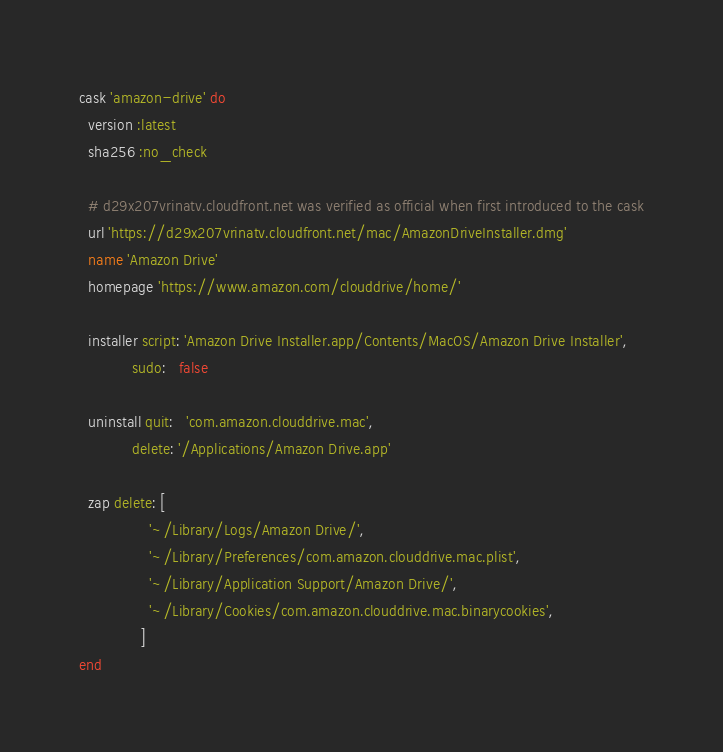Convert code to text. <code><loc_0><loc_0><loc_500><loc_500><_Ruby_>cask 'amazon-drive' do
  version :latest
  sha256 :no_check

  # d29x207vrinatv.cloudfront.net was verified as official when first introduced to the cask
  url 'https://d29x207vrinatv.cloudfront.net/mac/AmazonDriveInstaller.dmg'
  name 'Amazon Drive'
  homepage 'https://www.amazon.com/clouddrive/home/'

  installer script: 'Amazon Drive Installer.app/Contents/MacOS/Amazon Drive Installer',
            sudo:   false

  uninstall quit:   'com.amazon.clouddrive.mac',
            delete: '/Applications/Amazon Drive.app'

  zap delete: [
                '~/Library/Logs/Amazon Drive/',
                '~/Library/Preferences/com.amazon.clouddrive.mac.plist',
                '~/Library/Application Support/Amazon Drive/',
                '~/Library/Cookies/com.amazon.clouddrive.mac.binarycookies',
              ]
end
</code> 